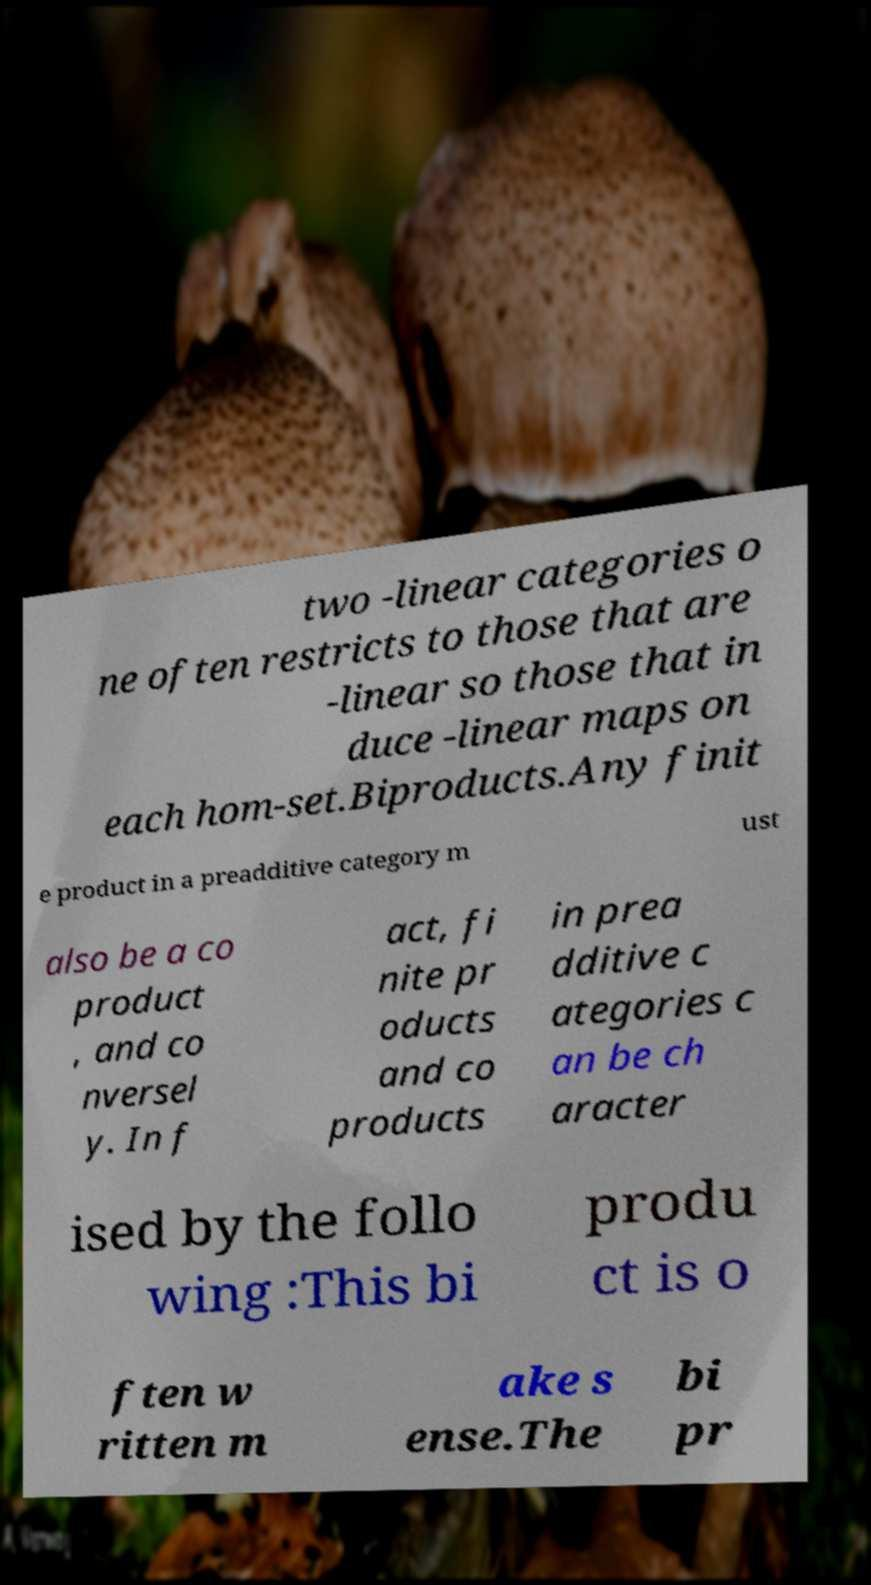Could you assist in decoding the text presented in this image and type it out clearly? two -linear categories o ne often restricts to those that are -linear so those that in duce -linear maps on each hom-set.Biproducts.Any finit e product in a preadditive category m ust also be a co product , and co nversel y. In f act, fi nite pr oducts and co products in prea dditive c ategories c an be ch aracter ised by the follo wing :This bi produ ct is o ften w ritten m ake s ense.The bi pr 